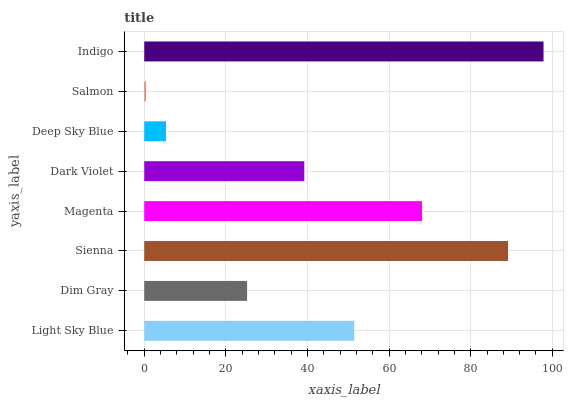Is Salmon the minimum?
Answer yes or no. Yes. Is Indigo the maximum?
Answer yes or no. Yes. Is Dim Gray the minimum?
Answer yes or no. No. Is Dim Gray the maximum?
Answer yes or no. No. Is Light Sky Blue greater than Dim Gray?
Answer yes or no. Yes. Is Dim Gray less than Light Sky Blue?
Answer yes or no. Yes. Is Dim Gray greater than Light Sky Blue?
Answer yes or no. No. Is Light Sky Blue less than Dim Gray?
Answer yes or no. No. Is Light Sky Blue the high median?
Answer yes or no. Yes. Is Dark Violet the low median?
Answer yes or no. Yes. Is Indigo the high median?
Answer yes or no. No. Is Light Sky Blue the low median?
Answer yes or no. No. 